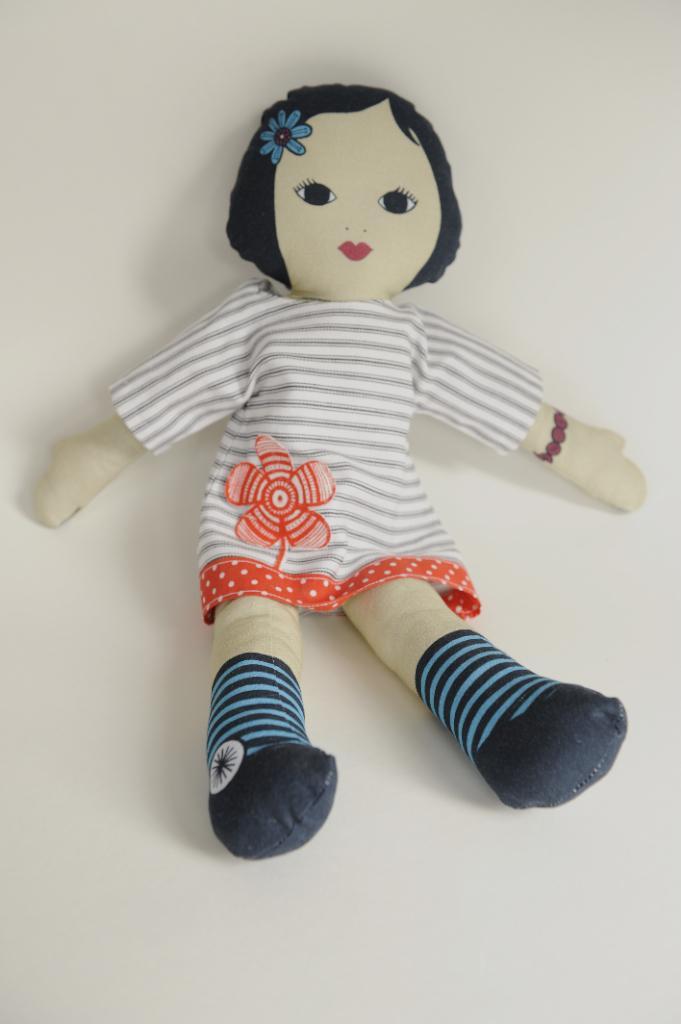In one or two sentences, can you explain what this image depicts? In this image in the center there is one toy, and there is a white background. 